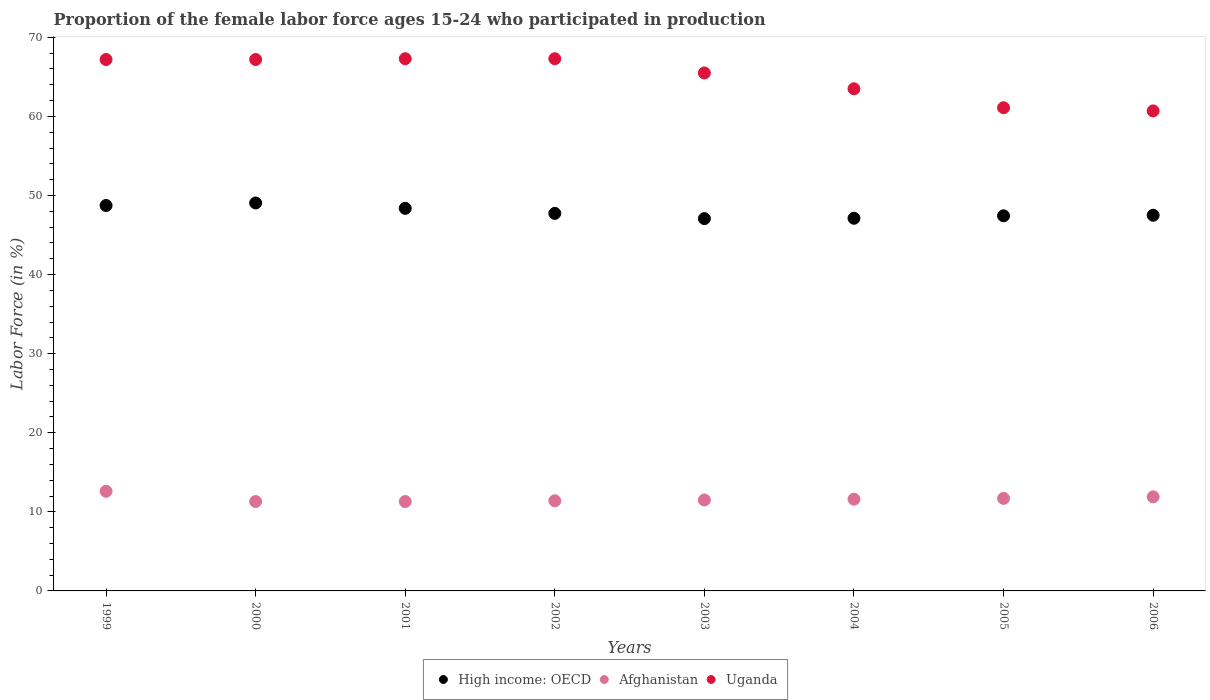How many different coloured dotlines are there?
Make the answer very short. 3. What is the proportion of the female labor force who participated in production in Uganda in 2006?
Your answer should be very brief. 60.7. Across all years, what is the maximum proportion of the female labor force who participated in production in Uganda?
Your answer should be compact. 67.3. Across all years, what is the minimum proportion of the female labor force who participated in production in Afghanistan?
Offer a very short reply. 11.3. In which year was the proportion of the female labor force who participated in production in Uganda maximum?
Provide a short and direct response. 2001. In which year was the proportion of the female labor force who participated in production in Uganda minimum?
Give a very brief answer. 2006. What is the total proportion of the female labor force who participated in production in Uganda in the graph?
Your response must be concise. 519.8. What is the difference between the proportion of the female labor force who participated in production in Afghanistan in 2003 and that in 2006?
Give a very brief answer. -0.4. What is the difference between the proportion of the female labor force who participated in production in High income: OECD in 2003 and the proportion of the female labor force who participated in production in Afghanistan in 2000?
Keep it short and to the point. 35.78. What is the average proportion of the female labor force who participated in production in Uganda per year?
Offer a very short reply. 64.97. In the year 1999, what is the difference between the proportion of the female labor force who participated in production in High income: OECD and proportion of the female labor force who participated in production in Uganda?
Offer a very short reply. -18.46. What is the ratio of the proportion of the female labor force who participated in production in Uganda in 2002 to that in 2006?
Offer a terse response. 1.11. Is the difference between the proportion of the female labor force who participated in production in High income: OECD in 2000 and 2006 greater than the difference between the proportion of the female labor force who participated in production in Uganda in 2000 and 2006?
Keep it short and to the point. No. What is the difference between the highest and the second highest proportion of the female labor force who participated in production in High income: OECD?
Keep it short and to the point. 0.32. What is the difference between the highest and the lowest proportion of the female labor force who participated in production in Uganda?
Your answer should be very brief. 6.6. Is the proportion of the female labor force who participated in production in Afghanistan strictly less than the proportion of the female labor force who participated in production in Uganda over the years?
Make the answer very short. Yes. How many years are there in the graph?
Offer a terse response. 8. Are the values on the major ticks of Y-axis written in scientific E-notation?
Give a very brief answer. No. Does the graph contain any zero values?
Your answer should be very brief. No. How many legend labels are there?
Ensure brevity in your answer.  3. What is the title of the graph?
Offer a terse response. Proportion of the female labor force ages 15-24 who participated in production. Does "Angola" appear as one of the legend labels in the graph?
Ensure brevity in your answer.  No. What is the label or title of the Y-axis?
Your answer should be compact. Labor Force (in %). What is the Labor Force (in %) in High income: OECD in 1999?
Ensure brevity in your answer.  48.74. What is the Labor Force (in %) in Afghanistan in 1999?
Provide a short and direct response. 12.6. What is the Labor Force (in %) of Uganda in 1999?
Your answer should be very brief. 67.2. What is the Labor Force (in %) in High income: OECD in 2000?
Your response must be concise. 49.06. What is the Labor Force (in %) in Afghanistan in 2000?
Provide a short and direct response. 11.3. What is the Labor Force (in %) in Uganda in 2000?
Ensure brevity in your answer.  67.2. What is the Labor Force (in %) in High income: OECD in 2001?
Offer a terse response. 48.38. What is the Labor Force (in %) of Afghanistan in 2001?
Make the answer very short. 11.3. What is the Labor Force (in %) of Uganda in 2001?
Your answer should be compact. 67.3. What is the Labor Force (in %) in High income: OECD in 2002?
Your response must be concise. 47.74. What is the Labor Force (in %) in Afghanistan in 2002?
Ensure brevity in your answer.  11.4. What is the Labor Force (in %) in Uganda in 2002?
Your answer should be compact. 67.3. What is the Labor Force (in %) in High income: OECD in 2003?
Provide a succinct answer. 47.08. What is the Labor Force (in %) of Afghanistan in 2003?
Make the answer very short. 11.5. What is the Labor Force (in %) in Uganda in 2003?
Offer a very short reply. 65.5. What is the Labor Force (in %) of High income: OECD in 2004?
Your answer should be compact. 47.12. What is the Labor Force (in %) in Afghanistan in 2004?
Provide a short and direct response. 11.6. What is the Labor Force (in %) in Uganda in 2004?
Your response must be concise. 63.5. What is the Labor Force (in %) of High income: OECD in 2005?
Provide a succinct answer. 47.44. What is the Labor Force (in %) in Afghanistan in 2005?
Provide a succinct answer. 11.7. What is the Labor Force (in %) of Uganda in 2005?
Offer a terse response. 61.1. What is the Labor Force (in %) of High income: OECD in 2006?
Your response must be concise. 47.51. What is the Labor Force (in %) in Afghanistan in 2006?
Give a very brief answer. 11.9. What is the Labor Force (in %) of Uganda in 2006?
Make the answer very short. 60.7. Across all years, what is the maximum Labor Force (in %) in High income: OECD?
Give a very brief answer. 49.06. Across all years, what is the maximum Labor Force (in %) in Afghanistan?
Offer a terse response. 12.6. Across all years, what is the maximum Labor Force (in %) in Uganda?
Provide a short and direct response. 67.3. Across all years, what is the minimum Labor Force (in %) in High income: OECD?
Offer a terse response. 47.08. Across all years, what is the minimum Labor Force (in %) of Afghanistan?
Your answer should be very brief. 11.3. Across all years, what is the minimum Labor Force (in %) of Uganda?
Provide a short and direct response. 60.7. What is the total Labor Force (in %) of High income: OECD in the graph?
Offer a terse response. 383.07. What is the total Labor Force (in %) of Afghanistan in the graph?
Make the answer very short. 93.3. What is the total Labor Force (in %) in Uganda in the graph?
Provide a short and direct response. 519.8. What is the difference between the Labor Force (in %) in High income: OECD in 1999 and that in 2000?
Keep it short and to the point. -0.32. What is the difference between the Labor Force (in %) in Afghanistan in 1999 and that in 2000?
Offer a terse response. 1.3. What is the difference between the Labor Force (in %) of Uganda in 1999 and that in 2000?
Your response must be concise. 0. What is the difference between the Labor Force (in %) in High income: OECD in 1999 and that in 2001?
Keep it short and to the point. 0.36. What is the difference between the Labor Force (in %) of Afghanistan in 1999 and that in 2001?
Provide a short and direct response. 1.3. What is the difference between the Labor Force (in %) in Uganda in 1999 and that in 2001?
Your response must be concise. -0.1. What is the difference between the Labor Force (in %) of Afghanistan in 1999 and that in 2002?
Provide a succinct answer. 1.2. What is the difference between the Labor Force (in %) of Uganda in 1999 and that in 2002?
Your answer should be compact. -0.1. What is the difference between the Labor Force (in %) in High income: OECD in 1999 and that in 2003?
Your response must be concise. 1.66. What is the difference between the Labor Force (in %) of Afghanistan in 1999 and that in 2003?
Keep it short and to the point. 1.1. What is the difference between the Labor Force (in %) in High income: OECD in 1999 and that in 2004?
Keep it short and to the point. 1.61. What is the difference between the Labor Force (in %) in Afghanistan in 1999 and that in 2004?
Offer a terse response. 1. What is the difference between the Labor Force (in %) of High income: OECD in 1999 and that in 2005?
Offer a very short reply. 1.3. What is the difference between the Labor Force (in %) in High income: OECD in 1999 and that in 2006?
Your answer should be compact. 1.23. What is the difference between the Labor Force (in %) of Afghanistan in 1999 and that in 2006?
Your answer should be very brief. 0.7. What is the difference between the Labor Force (in %) of High income: OECD in 2000 and that in 2001?
Your answer should be compact. 0.68. What is the difference between the Labor Force (in %) in Afghanistan in 2000 and that in 2001?
Provide a short and direct response. 0. What is the difference between the Labor Force (in %) in Uganda in 2000 and that in 2001?
Make the answer very short. -0.1. What is the difference between the Labor Force (in %) in High income: OECD in 2000 and that in 2002?
Offer a terse response. 1.32. What is the difference between the Labor Force (in %) of High income: OECD in 2000 and that in 2003?
Offer a very short reply. 1.98. What is the difference between the Labor Force (in %) in Afghanistan in 2000 and that in 2003?
Provide a short and direct response. -0.2. What is the difference between the Labor Force (in %) in High income: OECD in 2000 and that in 2004?
Offer a very short reply. 1.93. What is the difference between the Labor Force (in %) in Uganda in 2000 and that in 2004?
Offer a very short reply. 3.7. What is the difference between the Labor Force (in %) in High income: OECD in 2000 and that in 2005?
Offer a terse response. 1.62. What is the difference between the Labor Force (in %) in High income: OECD in 2000 and that in 2006?
Offer a terse response. 1.55. What is the difference between the Labor Force (in %) in Afghanistan in 2000 and that in 2006?
Make the answer very short. -0.6. What is the difference between the Labor Force (in %) in High income: OECD in 2001 and that in 2002?
Keep it short and to the point. 0.64. What is the difference between the Labor Force (in %) of High income: OECD in 2001 and that in 2003?
Your response must be concise. 1.3. What is the difference between the Labor Force (in %) in Uganda in 2001 and that in 2003?
Provide a short and direct response. 1.8. What is the difference between the Labor Force (in %) in High income: OECD in 2001 and that in 2004?
Give a very brief answer. 1.26. What is the difference between the Labor Force (in %) of High income: OECD in 2001 and that in 2005?
Provide a short and direct response. 0.94. What is the difference between the Labor Force (in %) of Afghanistan in 2001 and that in 2005?
Provide a succinct answer. -0.4. What is the difference between the Labor Force (in %) in High income: OECD in 2001 and that in 2006?
Provide a short and direct response. 0.87. What is the difference between the Labor Force (in %) in Afghanistan in 2001 and that in 2006?
Your answer should be very brief. -0.6. What is the difference between the Labor Force (in %) of High income: OECD in 2002 and that in 2003?
Your answer should be very brief. 0.66. What is the difference between the Labor Force (in %) of High income: OECD in 2002 and that in 2004?
Offer a terse response. 0.62. What is the difference between the Labor Force (in %) of Afghanistan in 2002 and that in 2004?
Make the answer very short. -0.2. What is the difference between the Labor Force (in %) of High income: OECD in 2002 and that in 2005?
Offer a very short reply. 0.3. What is the difference between the Labor Force (in %) of Afghanistan in 2002 and that in 2005?
Offer a very short reply. -0.3. What is the difference between the Labor Force (in %) of Uganda in 2002 and that in 2005?
Offer a very short reply. 6.2. What is the difference between the Labor Force (in %) in High income: OECD in 2002 and that in 2006?
Offer a terse response. 0.23. What is the difference between the Labor Force (in %) in Afghanistan in 2002 and that in 2006?
Your answer should be compact. -0.5. What is the difference between the Labor Force (in %) in High income: OECD in 2003 and that in 2004?
Make the answer very short. -0.04. What is the difference between the Labor Force (in %) in Uganda in 2003 and that in 2004?
Your response must be concise. 2. What is the difference between the Labor Force (in %) in High income: OECD in 2003 and that in 2005?
Your answer should be very brief. -0.35. What is the difference between the Labor Force (in %) in High income: OECD in 2003 and that in 2006?
Ensure brevity in your answer.  -0.42. What is the difference between the Labor Force (in %) in Afghanistan in 2003 and that in 2006?
Offer a very short reply. -0.4. What is the difference between the Labor Force (in %) in High income: OECD in 2004 and that in 2005?
Your answer should be compact. -0.31. What is the difference between the Labor Force (in %) in Uganda in 2004 and that in 2005?
Provide a succinct answer. 2.4. What is the difference between the Labor Force (in %) of High income: OECD in 2004 and that in 2006?
Offer a terse response. -0.38. What is the difference between the Labor Force (in %) of Uganda in 2004 and that in 2006?
Ensure brevity in your answer.  2.8. What is the difference between the Labor Force (in %) in High income: OECD in 2005 and that in 2006?
Provide a succinct answer. -0.07. What is the difference between the Labor Force (in %) in High income: OECD in 1999 and the Labor Force (in %) in Afghanistan in 2000?
Provide a short and direct response. 37.44. What is the difference between the Labor Force (in %) in High income: OECD in 1999 and the Labor Force (in %) in Uganda in 2000?
Your response must be concise. -18.46. What is the difference between the Labor Force (in %) in Afghanistan in 1999 and the Labor Force (in %) in Uganda in 2000?
Make the answer very short. -54.6. What is the difference between the Labor Force (in %) of High income: OECD in 1999 and the Labor Force (in %) of Afghanistan in 2001?
Your answer should be very brief. 37.44. What is the difference between the Labor Force (in %) of High income: OECD in 1999 and the Labor Force (in %) of Uganda in 2001?
Give a very brief answer. -18.56. What is the difference between the Labor Force (in %) in Afghanistan in 1999 and the Labor Force (in %) in Uganda in 2001?
Offer a terse response. -54.7. What is the difference between the Labor Force (in %) in High income: OECD in 1999 and the Labor Force (in %) in Afghanistan in 2002?
Your response must be concise. 37.34. What is the difference between the Labor Force (in %) of High income: OECD in 1999 and the Labor Force (in %) of Uganda in 2002?
Ensure brevity in your answer.  -18.56. What is the difference between the Labor Force (in %) in Afghanistan in 1999 and the Labor Force (in %) in Uganda in 2002?
Your answer should be very brief. -54.7. What is the difference between the Labor Force (in %) of High income: OECD in 1999 and the Labor Force (in %) of Afghanistan in 2003?
Keep it short and to the point. 37.24. What is the difference between the Labor Force (in %) in High income: OECD in 1999 and the Labor Force (in %) in Uganda in 2003?
Give a very brief answer. -16.76. What is the difference between the Labor Force (in %) in Afghanistan in 1999 and the Labor Force (in %) in Uganda in 2003?
Ensure brevity in your answer.  -52.9. What is the difference between the Labor Force (in %) in High income: OECD in 1999 and the Labor Force (in %) in Afghanistan in 2004?
Your response must be concise. 37.14. What is the difference between the Labor Force (in %) in High income: OECD in 1999 and the Labor Force (in %) in Uganda in 2004?
Your answer should be compact. -14.76. What is the difference between the Labor Force (in %) of Afghanistan in 1999 and the Labor Force (in %) of Uganda in 2004?
Your response must be concise. -50.9. What is the difference between the Labor Force (in %) of High income: OECD in 1999 and the Labor Force (in %) of Afghanistan in 2005?
Your answer should be very brief. 37.04. What is the difference between the Labor Force (in %) of High income: OECD in 1999 and the Labor Force (in %) of Uganda in 2005?
Your answer should be very brief. -12.36. What is the difference between the Labor Force (in %) of Afghanistan in 1999 and the Labor Force (in %) of Uganda in 2005?
Offer a terse response. -48.5. What is the difference between the Labor Force (in %) in High income: OECD in 1999 and the Labor Force (in %) in Afghanistan in 2006?
Provide a succinct answer. 36.84. What is the difference between the Labor Force (in %) in High income: OECD in 1999 and the Labor Force (in %) in Uganda in 2006?
Offer a terse response. -11.96. What is the difference between the Labor Force (in %) of Afghanistan in 1999 and the Labor Force (in %) of Uganda in 2006?
Make the answer very short. -48.1. What is the difference between the Labor Force (in %) of High income: OECD in 2000 and the Labor Force (in %) of Afghanistan in 2001?
Offer a very short reply. 37.76. What is the difference between the Labor Force (in %) in High income: OECD in 2000 and the Labor Force (in %) in Uganda in 2001?
Your response must be concise. -18.24. What is the difference between the Labor Force (in %) in Afghanistan in 2000 and the Labor Force (in %) in Uganda in 2001?
Keep it short and to the point. -56. What is the difference between the Labor Force (in %) of High income: OECD in 2000 and the Labor Force (in %) of Afghanistan in 2002?
Offer a terse response. 37.66. What is the difference between the Labor Force (in %) in High income: OECD in 2000 and the Labor Force (in %) in Uganda in 2002?
Ensure brevity in your answer.  -18.24. What is the difference between the Labor Force (in %) of Afghanistan in 2000 and the Labor Force (in %) of Uganda in 2002?
Offer a terse response. -56. What is the difference between the Labor Force (in %) in High income: OECD in 2000 and the Labor Force (in %) in Afghanistan in 2003?
Your answer should be compact. 37.56. What is the difference between the Labor Force (in %) of High income: OECD in 2000 and the Labor Force (in %) of Uganda in 2003?
Your response must be concise. -16.44. What is the difference between the Labor Force (in %) of Afghanistan in 2000 and the Labor Force (in %) of Uganda in 2003?
Keep it short and to the point. -54.2. What is the difference between the Labor Force (in %) of High income: OECD in 2000 and the Labor Force (in %) of Afghanistan in 2004?
Offer a very short reply. 37.46. What is the difference between the Labor Force (in %) in High income: OECD in 2000 and the Labor Force (in %) in Uganda in 2004?
Provide a short and direct response. -14.44. What is the difference between the Labor Force (in %) of Afghanistan in 2000 and the Labor Force (in %) of Uganda in 2004?
Give a very brief answer. -52.2. What is the difference between the Labor Force (in %) of High income: OECD in 2000 and the Labor Force (in %) of Afghanistan in 2005?
Your answer should be very brief. 37.36. What is the difference between the Labor Force (in %) in High income: OECD in 2000 and the Labor Force (in %) in Uganda in 2005?
Make the answer very short. -12.04. What is the difference between the Labor Force (in %) of Afghanistan in 2000 and the Labor Force (in %) of Uganda in 2005?
Give a very brief answer. -49.8. What is the difference between the Labor Force (in %) in High income: OECD in 2000 and the Labor Force (in %) in Afghanistan in 2006?
Make the answer very short. 37.16. What is the difference between the Labor Force (in %) of High income: OECD in 2000 and the Labor Force (in %) of Uganda in 2006?
Your answer should be very brief. -11.64. What is the difference between the Labor Force (in %) in Afghanistan in 2000 and the Labor Force (in %) in Uganda in 2006?
Your response must be concise. -49.4. What is the difference between the Labor Force (in %) of High income: OECD in 2001 and the Labor Force (in %) of Afghanistan in 2002?
Provide a short and direct response. 36.98. What is the difference between the Labor Force (in %) in High income: OECD in 2001 and the Labor Force (in %) in Uganda in 2002?
Offer a very short reply. -18.92. What is the difference between the Labor Force (in %) in Afghanistan in 2001 and the Labor Force (in %) in Uganda in 2002?
Offer a terse response. -56. What is the difference between the Labor Force (in %) in High income: OECD in 2001 and the Labor Force (in %) in Afghanistan in 2003?
Your answer should be compact. 36.88. What is the difference between the Labor Force (in %) in High income: OECD in 2001 and the Labor Force (in %) in Uganda in 2003?
Offer a terse response. -17.12. What is the difference between the Labor Force (in %) in Afghanistan in 2001 and the Labor Force (in %) in Uganda in 2003?
Your response must be concise. -54.2. What is the difference between the Labor Force (in %) of High income: OECD in 2001 and the Labor Force (in %) of Afghanistan in 2004?
Make the answer very short. 36.78. What is the difference between the Labor Force (in %) in High income: OECD in 2001 and the Labor Force (in %) in Uganda in 2004?
Ensure brevity in your answer.  -15.12. What is the difference between the Labor Force (in %) of Afghanistan in 2001 and the Labor Force (in %) of Uganda in 2004?
Give a very brief answer. -52.2. What is the difference between the Labor Force (in %) of High income: OECD in 2001 and the Labor Force (in %) of Afghanistan in 2005?
Make the answer very short. 36.68. What is the difference between the Labor Force (in %) of High income: OECD in 2001 and the Labor Force (in %) of Uganda in 2005?
Provide a short and direct response. -12.72. What is the difference between the Labor Force (in %) in Afghanistan in 2001 and the Labor Force (in %) in Uganda in 2005?
Offer a very short reply. -49.8. What is the difference between the Labor Force (in %) of High income: OECD in 2001 and the Labor Force (in %) of Afghanistan in 2006?
Provide a short and direct response. 36.48. What is the difference between the Labor Force (in %) in High income: OECD in 2001 and the Labor Force (in %) in Uganda in 2006?
Your answer should be very brief. -12.32. What is the difference between the Labor Force (in %) of Afghanistan in 2001 and the Labor Force (in %) of Uganda in 2006?
Give a very brief answer. -49.4. What is the difference between the Labor Force (in %) in High income: OECD in 2002 and the Labor Force (in %) in Afghanistan in 2003?
Provide a short and direct response. 36.24. What is the difference between the Labor Force (in %) in High income: OECD in 2002 and the Labor Force (in %) in Uganda in 2003?
Offer a terse response. -17.76. What is the difference between the Labor Force (in %) of Afghanistan in 2002 and the Labor Force (in %) of Uganda in 2003?
Your response must be concise. -54.1. What is the difference between the Labor Force (in %) of High income: OECD in 2002 and the Labor Force (in %) of Afghanistan in 2004?
Give a very brief answer. 36.14. What is the difference between the Labor Force (in %) in High income: OECD in 2002 and the Labor Force (in %) in Uganda in 2004?
Give a very brief answer. -15.76. What is the difference between the Labor Force (in %) in Afghanistan in 2002 and the Labor Force (in %) in Uganda in 2004?
Provide a short and direct response. -52.1. What is the difference between the Labor Force (in %) of High income: OECD in 2002 and the Labor Force (in %) of Afghanistan in 2005?
Your answer should be very brief. 36.04. What is the difference between the Labor Force (in %) of High income: OECD in 2002 and the Labor Force (in %) of Uganda in 2005?
Offer a very short reply. -13.36. What is the difference between the Labor Force (in %) of Afghanistan in 2002 and the Labor Force (in %) of Uganda in 2005?
Provide a short and direct response. -49.7. What is the difference between the Labor Force (in %) of High income: OECD in 2002 and the Labor Force (in %) of Afghanistan in 2006?
Make the answer very short. 35.84. What is the difference between the Labor Force (in %) in High income: OECD in 2002 and the Labor Force (in %) in Uganda in 2006?
Offer a terse response. -12.96. What is the difference between the Labor Force (in %) of Afghanistan in 2002 and the Labor Force (in %) of Uganda in 2006?
Make the answer very short. -49.3. What is the difference between the Labor Force (in %) of High income: OECD in 2003 and the Labor Force (in %) of Afghanistan in 2004?
Your response must be concise. 35.48. What is the difference between the Labor Force (in %) of High income: OECD in 2003 and the Labor Force (in %) of Uganda in 2004?
Make the answer very short. -16.42. What is the difference between the Labor Force (in %) in Afghanistan in 2003 and the Labor Force (in %) in Uganda in 2004?
Ensure brevity in your answer.  -52. What is the difference between the Labor Force (in %) of High income: OECD in 2003 and the Labor Force (in %) of Afghanistan in 2005?
Provide a short and direct response. 35.38. What is the difference between the Labor Force (in %) of High income: OECD in 2003 and the Labor Force (in %) of Uganda in 2005?
Keep it short and to the point. -14.02. What is the difference between the Labor Force (in %) of Afghanistan in 2003 and the Labor Force (in %) of Uganda in 2005?
Keep it short and to the point. -49.6. What is the difference between the Labor Force (in %) in High income: OECD in 2003 and the Labor Force (in %) in Afghanistan in 2006?
Offer a terse response. 35.18. What is the difference between the Labor Force (in %) in High income: OECD in 2003 and the Labor Force (in %) in Uganda in 2006?
Offer a terse response. -13.62. What is the difference between the Labor Force (in %) in Afghanistan in 2003 and the Labor Force (in %) in Uganda in 2006?
Make the answer very short. -49.2. What is the difference between the Labor Force (in %) in High income: OECD in 2004 and the Labor Force (in %) in Afghanistan in 2005?
Provide a short and direct response. 35.42. What is the difference between the Labor Force (in %) of High income: OECD in 2004 and the Labor Force (in %) of Uganda in 2005?
Your answer should be compact. -13.98. What is the difference between the Labor Force (in %) in Afghanistan in 2004 and the Labor Force (in %) in Uganda in 2005?
Your answer should be very brief. -49.5. What is the difference between the Labor Force (in %) of High income: OECD in 2004 and the Labor Force (in %) of Afghanistan in 2006?
Your answer should be compact. 35.22. What is the difference between the Labor Force (in %) in High income: OECD in 2004 and the Labor Force (in %) in Uganda in 2006?
Your answer should be compact. -13.58. What is the difference between the Labor Force (in %) in Afghanistan in 2004 and the Labor Force (in %) in Uganda in 2006?
Provide a succinct answer. -49.1. What is the difference between the Labor Force (in %) of High income: OECD in 2005 and the Labor Force (in %) of Afghanistan in 2006?
Your response must be concise. 35.54. What is the difference between the Labor Force (in %) of High income: OECD in 2005 and the Labor Force (in %) of Uganda in 2006?
Offer a very short reply. -13.26. What is the difference between the Labor Force (in %) of Afghanistan in 2005 and the Labor Force (in %) of Uganda in 2006?
Offer a very short reply. -49. What is the average Labor Force (in %) in High income: OECD per year?
Offer a very short reply. 47.88. What is the average Labor Force (in %) of Afghanistan per year?
Give a very brief answer. 11.66. What is the average Labor Force (in %) of Uganda per year?
Your answer should be compact. 64.97. In the year 1999, what is the difference between the Labor Force (in %) in High income: OECD and Labor Force (in %) in Afghanistan?
Your answer should be very brief. 36.14. In the year 1999, what is the difference between the Labor Force (in %) in High income: OECD and Labor Force (in %) in Uganda?
Offer a very short reply. -18.46. In the year 1999, what is the difference between the Labor Force (in %) in Afghanistan and Labor Force (in %) in Uganda?
Offer a very short reply. -54.6. In the year 2000, what is the difference between the Labor Force (in %) of High income: OECD and Labor Force (in %) of Afghanistan?
Give a very brief answer. 37.76. In the year 2000, what is the difference between the Labor Force (in %) in High income: OECD and Labor Force (in %) in Uganda?
Provide a short and direct response. -18.14. In the year 2000, what is the difference between the Labor Force (in %) in Afghanistan and Labor Force (in %) in Uganda?
Offer a very short reply. -55.9. In the year 2001, what is the difference between the Labor Force (in %) in High income: OECD and Labor Force (in %) in Afghanistan?
Provide a succinct answer. 37.08. In the year 2001, what is the difference between the Labor Force (in %) of High income: OECD and Labor Force (in %) of Uganda?
Your response must be concise. -18.92. In the year 2001, what is the difference between the Labor Force (in %) of Afghanistan and Labor Force (in %) of Uganda?
Provide a short and direct response. -56. In the year 2002, what is the difference between the Labor Force (in %) in High income: OECD and Labor Force (in %) in Afghanistan?
Offer a very short reply. 36.34. In the year 2002, what is the difference between the Labor Force (in %) of High income: OECD and Labor Force (in %) of Uganda?
Give a very brief answer. -19.56. In the year 2002, what is the difference between the Labor Force (in %) of Afghanistan and Labor Force (in %) of Uganda?
Provide a short and direct response. -55.9. In the year 2003, what is the difference between the Labor Force (in %) in High income: OECD and Labor Force (in %) in Afghanistan?
Keep it short and to the point. 35.58. In the year 2003, what is the difference between the Labor Force (in %) of High income: OECD and Labor Force (in %) of Uganda?
Keep it short and to the point. -18.42. In the year 2003, what is the difference between the Labor Force (in %) in Afghanistan and Labor Force (in %) in Uganda?
Ensure brevity in your answer.  -54. In the year 2004, what is the difference between the Labor Force (in %) of High income: OECD and Labor Force (in %) of Afghanistan?
Offer a terse response. 35.52. In the year 2004, what is the difference between the Labor Force (in %) of High income: OECD and Labor Force (in %) of Uganda?
Offer a terse response. -16.38. In the year 2004, what is the difference between the Labor Force (in %) in Afghanistan and Labor Force (in %) in Uganda?
Provide a succinct answer. -51.9. In the year 2005, what is the difference between the Labor Force (in %) of High income: OECD and Labor Force (in %) of Afghanistan?
Offer a very short reply. 35.74. In the year 2005, what is the difference between the Labor Force (in %) in High income: OECD and Labor Force (in %) in Uganda?
Keep it short and to the point. -13.66. In the year 2005, what is the difference between the Labor Force (in %) in Afghanistan and Labor Force (in %) in Uganda?
Your answer should be very brief. -49.4. In the year 2006, what is the difference between the Labor Force (in %) in High income: OECD and Labor Force (in %) in Afghanistan?
Provide a short and direct response. 35.61. In the year 2006, what is the difference between the Labor Force (in %) of High income: OECD and Labor Force (in %) of Uganda?
Keep it short and to the point. -13.19. In the year 2006, what is the difference between the Labor Force (in %) in Afghanistan and Labor Force (in %) in Uganda?
Your answer should be very brief. -48.8. What is the ratio of the Labor Force (in %) of High income: OECD in 1999 to that in 2000?
Give a very brief answer. 0.99. What is the ratio of the Labor Force (in %) of Afghanistan in 1999 to that in 2000?
Your answer should be compact. 1.11. What is the ratio of the Labor Force (in %) of Uganda in 1999 to that in 2000?
Your answer should be compact. 1. What is the ratio of the Labor Force (in %) of High income: OECD in 1999 to that in 2001?
Your answer should be compact. 1.01. What is the ratio of the Labor Force (in %) in Afghanistan in 1999 to that in 2001?
Your response must be concise. 1.11. What is the ratio of the Labor Force (in %) of Uganda in 1999 to that in 2001?
Your answer should be very brief. 1. What is the ratio of the Labor Force (in %) of High income: OECD in 1999 to that in 2002?
Offer a very short reply. 1.02. What is the ratio of the Labor Force (in %) of Afghanistan in 1999 to that in 2002?
Keep it short and to the point. 1.11. What is the ratio of the Labor Force (in %) of Uganda in 1999 to that in 2002?
Keep it short and to the point. 1. What is the ratio of the Labor Force (in %) in High income: OECD in 1999 to that in 2003?
Make the answer very short. 1.04. What is the ratio of the Labor Force (in %) in Afghanistan in 1999 to that in 2003?
Your response must be concise. 1.1. What is the ratio of the Labor Force (in %) in Uganda in 1999 to that in 2003?
Provide a succinct answer. 1.03. What is the ratio of the Labor Force (in %) of High income: OECD in 1999 to that in 2004?
Make the answer very short. 1.03. What is the ratio of the Labor Force (in %) in Afghanistan in 1999 to that in 2004?
Keep it short and to the point. 1.09. What is the ratio of the Labor Force (in %) of Uganda in 1999 to that in 2004?
Ensure brevity in your answer.  1.06. What is the ratio of the Labor Force (in %) of High income: OECD in 1999 to that in 2005?
Provide a short and direct response. 1.03. What is the ratio of the Labor Force (in %) of Afghanistan in 1999 to that in 2005?
Your answer should be compact. 1.08. What is the ratio of the Labor Force (in %) in Uganda in 1999 to that in 2005?
Ensure brevity in your answer.  1.1. What is the ratio of the Labor Force (in %) in High income: OECD in 1999 to that in 2006?
Your answer should be compact. 1.03. What is the ratio of the Labor Force (in %) in Afghanistan in 1999 to that in 2006?
Your answer should be compact. 1.06. What is the ratio of the Labor Force (in %) of Uganda in 1999 to that in 2006?
Provide a short and direct response. 1.11. What is the ratio of the Labor Force (in %) in High income: OECD in 2000 to that in 2001?
Ensure brevity in your answer.  1.01. What is the ratio of the Labor Force (in %) in Afghanistan in 2000 to that in 2001?
Give a very brief answer. 1. What is the ratio of the Labor Force (in %) of High income: OECD in 2000 to that in 2002?
Your response must be concise. 1.03. What is the ratio of the Labor Force (in %) of Afghanistan in 2000 to that in 2002?
Make the answer very short. 0.99. What is the ratio of the Labor Force (in %) in Uganda in 2000 to that in 2002?
Offer a very short reply. 1. What is the ratio of the Labor Force (in %) of High income: OECD in 2000 to that in 2003?
Offer a terse response. 1.04. What is the ratio of the Labor Force (in %) of Afghanistan in 2000 to that in 2003?
Provide a short and direct response. 0.98. What is the ratio of the Labor Force (in %) in Uganda in 2000 to that in 2003?
Ensure brevity in your answer.  1.03. What is the ratio of the Labor Force (in %) of High income: OECD in 2000 to that in 2004?
Offer a very short reply. 1.04. What is the ratio of the Labor Force (in %) in Afghanistan in 2000 to that in 2004?
Keep it short and to the point. 0.97. What is the ratio of the Labor Force (in %) in Uganda in 2000 to that in 2004?
Provide a succinct answer. 1.06. What is the ratio of the Labor Force (in %) of High income: OECD in 2000 to that in 2005?
Offer a terse response. 1.03. What is the ratio of the Labor Force (in %) of Afghanistan in 2000 to that in 2005?
Offer a terse response. 0.97. What is the ratio of the Labor Force (in %) of Uganda in 2000 to that in 2005?
Provide a succinct answer. 1.1. What is the ratio of the Labor Force (in %) of High income: OECD in 2000 to that in 2006?
Ensure brevity in your answer.  1.03. What is the ratio of the Labor Force (in %) in Afghanistan in 2000 to that in 2006?
Give a very brief answer. 0.95. What is the ratio of the Labor Force (in %) of Uganda in 2000 to that in 2006?
Provide a succinct answer. 1.11. What is the ratio of the Labor Force (in %) of High income: OECD in 2001 to that in 2002?
Ensure brevity in your answer.  1.01. What is the ratio of the Labor Force (in %) in Afghanistan in 2001 to that in 2002?
Keep it short and to the point. 0.99. What is the ratio of the Labor Force (in %) in High income: OECD in 2001 to that in 2003?
Ensure brevity in your answer.  1.03. What is the ratio of the Labor Force (in %) in Afghanistan in 2001 to that in 2003?
Offer a terse response. 0.98. What is the ratio of the Labor Force (in %) in Uganda in 2001 to that in 2003?
Offer a terse response. 1.03. What is the ratio of the Labor Force (in %) of High income: OECD in 2001 to that in 2004?
Provide a short and direct response. 1.03. What is the ratio of the Labor Force (in %) of Afghanistan in 2001 to that in 2004?
Ensure brevity in your answer.  0.97. What is the ratio of the Labor Force (in %) in Uganda in 2001 to that in 2004?
Your response must be concise. 1.06. What is the ratio of the Labor Force (in %) in High income: OECD in 2001 to that in 2005?
Keep it short and to the point. 1.02. What is the ratio of the Labor Force (in %) in Afghanistan in 2001 to that in 2005?
Make the answer very short. 0.97. What is the ratio of the Labor Force (in %) of Uganda in 2001 to that in 2005?
Provide a succinct answer. 1.1. What is the ratio of the Labor Force (in %) of High income: OECD in 2001 to that in 2006?
Offer a terse response. 1.02. What is the ratio of the Labor Force (in %) of Afghanistan in 2001 to that in 2006?
Ensure brevity in your answer.  0.95. What is the ratio of the Labor Force (in %) in Uganda in 2001 to that in 2006?
Make the answer very short. 1.11. What is the ratio of the Labor Force (in %) of Uganda in 2002 to that in 2003?
Offer a very short reply. 1.03. What is the ratio of the Labor Force (in %) of High income: OECD in 2002 to that in 2004?
Ensure brevity in your answer.  1.01. What is the ratio of the Labor Force (in %) in Afghanistan in 2002 to that in 2004?
Ensure brevity in your answer.  0.98. What is the ratio of the Labor Force (in %) of Uganda in 2002 to that in 2004?
Provide a short and direct response. 1.06. What is the ratio of the Labor Force (in %) of High income: OECD in 2002 to that in 2005?
Your answer should be compact. 1.01. What is the ratio of the Labor Force (in %) of Afghanistan in 2002 to that in 2005?
Your response must be concise. 0.97. What is the ratio of the Labor Force (in %) of Uganda in 2002 to that in 2005?
Give a very brief answer. 1.1. What is the ratio of the Labor Force (in %) of Afghanistan in 2002 to that in 2006?
Provide a short and direct response. 0.96. What is the ratio of the Labor Force (in %) of Uganda in 2002 to that in 2006?
Give a very brief answer. 1.11. What is the ratio of the Labor Force (in %) of Afghanistan in 2003 to that in 2004?
Your answer should be compact. 0.99. What is the ratio of the Labor Force (in %) in Uganda in 2003 to that in 2004?
Keep it short and to the point. 1.03. What is the ratio of the Labor Force (in %) of High income: OECD in 2003 to that in 2005?
Offer a very short reply. 0.99. What is the ratio of the Labor Force (in %) in Afghanistan in 2003 to that in 2005?
Offer a terse response. 0.98. What is the ratio of the Labor Force (in %) of Uganda in 2003 to that in 2005?
Ensure brevity in your answer.  1.07. What is the ratio of the Labor Force (in %) in Afghanistan in 2003 to that in 2006?
Your response must be concise. 0.97. What is the ratio of the Labor Force (in %) of Uganda in 2003 to that in 2006?
Your answer should be very brief. 1.08. What is the ratio of the Labor Force (in %) in High income: OECD in 2004 to that in 2005?
Your response must be concise. 0.99. What is the ratio of the Labor Force (in %) in Uganda in 2004 to that in 2005?
Keep it short and to the point. 1.04. What is the ratio of the Labor Force (in %) in High income: OECD in 2004 to that in 2006?
Provide a short and direct response. 0.99. What is the ratio of the Labor Force (in %) of Afghanistan in 2004 to that in 2006?
Provide a succinct answer. 0.97. What is the ratio of the Labor Force (in %) in Uganda in 2004 to that in 2006?
Provide a succinct answer. 1.05. What is the ratio of the Labor Force (in %) in Afghanistan in 2005 to that in 2006?
Ensure brevity in your answer.  0.98. What is the ratio of the Labor Force (in %) in Uganda in 2005 to that in 2006?
Provide a short and direct response. 1.01. What is the difference between the highest and the second highest Labor Force (in %) of High income: OECD?
Your answer should be very brief. 0.32. What is the difference between the highest and the second highest Labor Force (in %) of Afghanistan?
Offer a very short reply. 0.7. What is the difference between the highest and the lowest Labor Force (in %) in High income: OECD?
Offer a very short reply. 1.98. What is the difference between the highest and the lowest Labor Force (in %) of Afghanistan?
Give a very brief answer. 1.3. What is the difference between the highest and the lowest Labor Force (in %) of Uganda?
Your response must be concise. 6.6. 